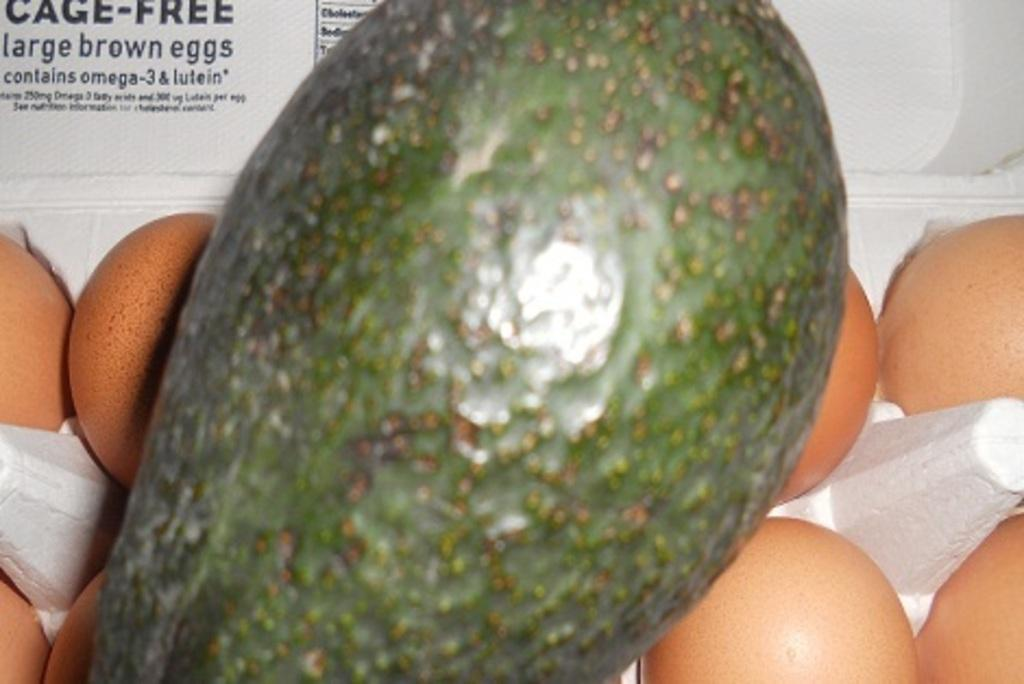What type of fruit is in the image? There is a green color fruit in the image. What other items can be seen in the image? There are eggs in the image, and they are orange in color. What is the color of the words on the left side of the image? The words on the left side of the image are black on a white background. What type of punishment is being given to the rat in the image? There is no rat present in the image, and therefore no punishment can be observed. 